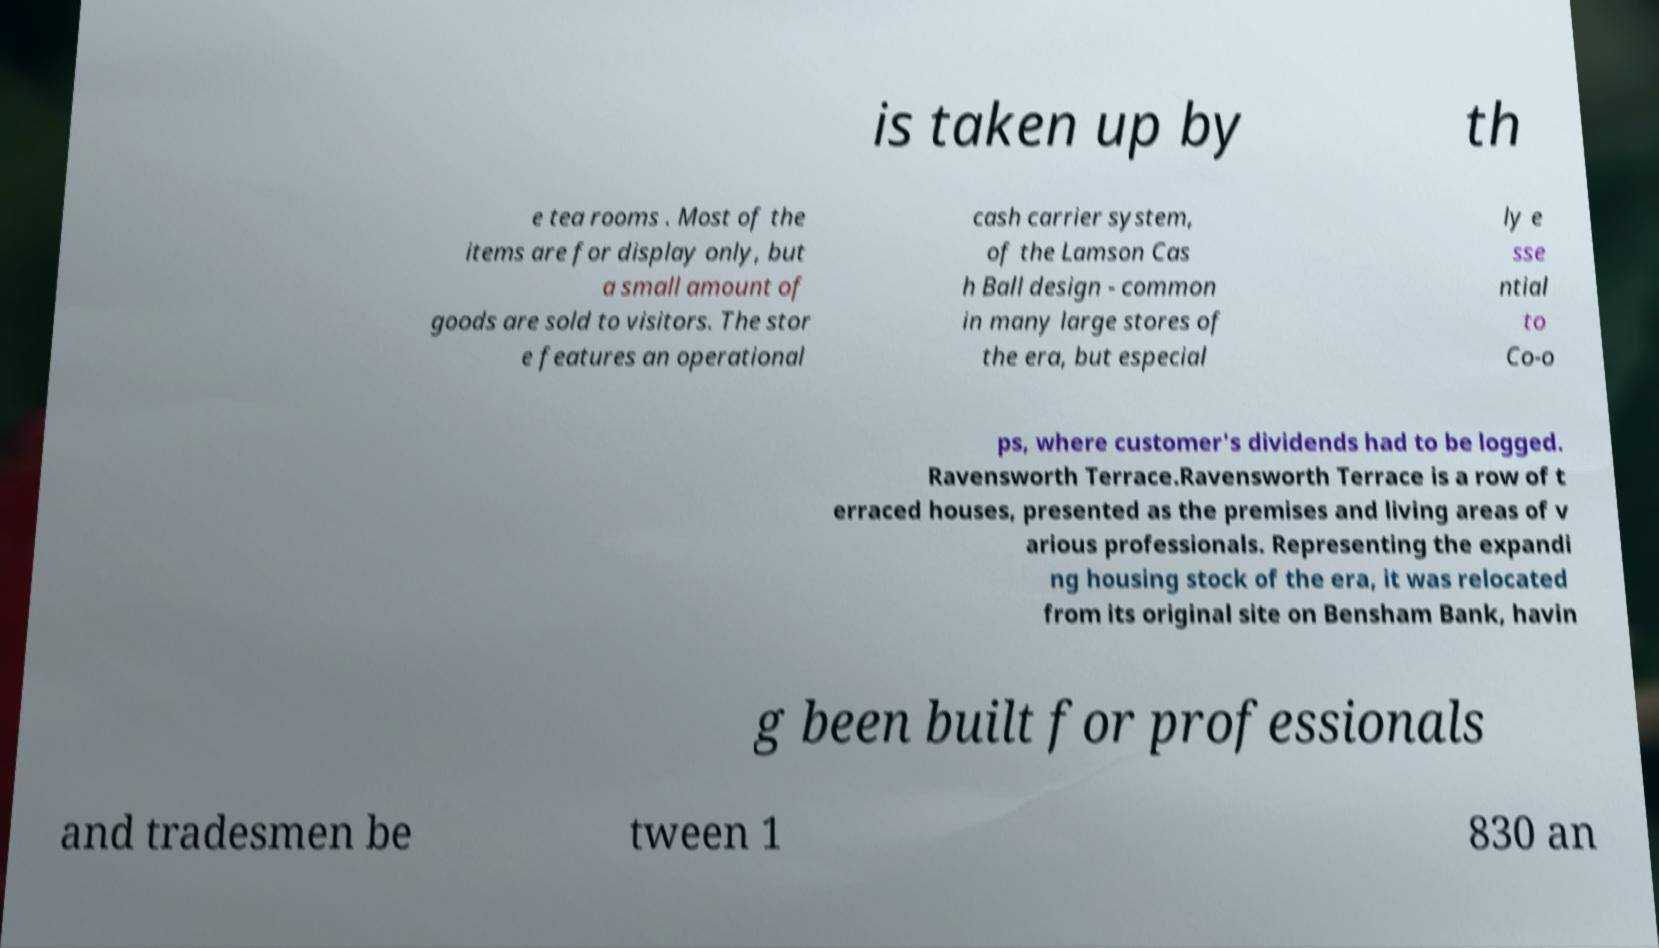Could you assist in decoding the text presented in this image and type it out clearly? is taken up by th e tea rooms . Most of the items are for display only, but a small amount of goods are sold to visitors. The stor e features an operational cash carrier system, of the Lamson Cas h Ball design - common in many large stores of the era, but especial ly e sse ntial to Co-o ps, where customer's dividends had to be logged. Ravensworth Terrace.Ravensworth Terrace is a row of t erraced houses, presented as the premises and living areas of v arious professionals. Representing the expandi ng housing stock of the era, it was relocated from its original site on Bensham Bank, havin g been built for professionals and tradesmen be tween 1 830 an 